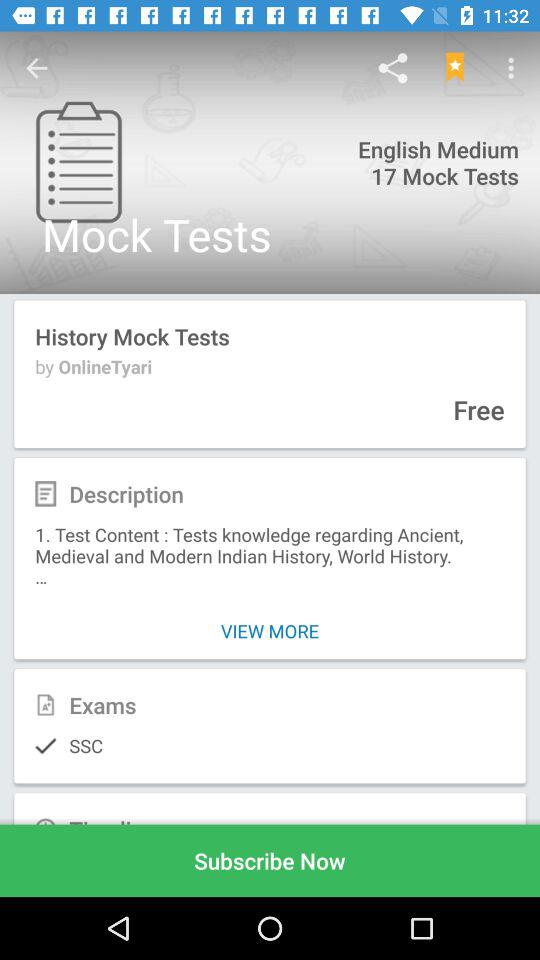How old is John?
When the provided information is insufficient, respond with <no answer>. <no answer> 